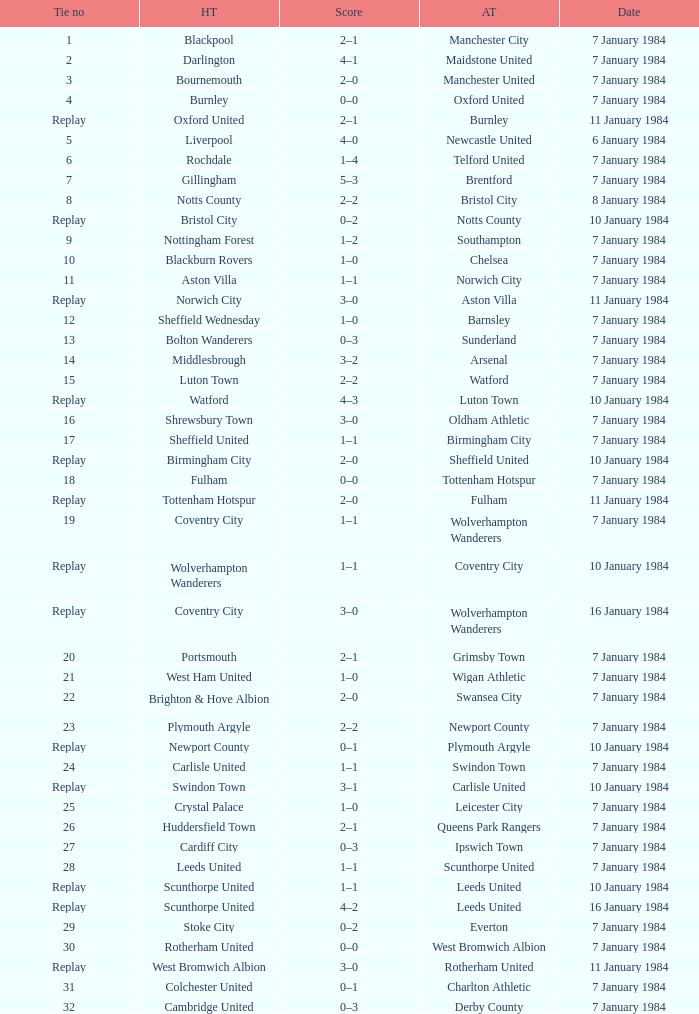Who was the away team against the home team Sheffield United? Birmingham City. Would you mind parsing the complete table? {'header': ['Tie no', 'HT', 'Score', 'AT', 'Date'], 'rows': [['1', 'Blackpool', '2–1', 'Manchester City', '7 January 1984'], ['2', 'Darlington', '4–1', 'Maidstone United', '7 January 1984'], ['3', 'Bournemouth', '2–0', 'Manchester United', '7 January 1984'], ['4', 'Burnley', '0–0', 'Oxford United', '7 January 1984'], ['Replay', 'Oxford United', '2–1', 'Burnley', '11 January 1984'], ['5', 'Liverpool', '4–0', 'Newcastle United', '6 January 1984'], ['6', 'Rochdale', '1–4', 'Telford United', '7 January 1984'], ['7', 'Gillingham', '5–3', 'Brentford', '7 January 1984'], ['8', 'Notts County', '2–2', 'Bristol City', '8 January 1984'], ['Replay', 'Bristol City', '0–2', 'Notts County', '10 January 1984'], ['9', 'Nottingham Forest', '1–2', 'Southampton', '7 January 1984'], ['10', 'Blackburn Rovers', '1–0', 'Chelsea', '7 January 1984'], ['11', 'Aston Villa', '1–1', 'Norwich City', '7 January 1984'], ['Replay', 'Norwich City', '3–0', 'Aston Villa', '11 January 1984'], ['12', 'Sheffield Wednesday', '1–0', 'Barnsley', '7 January 1984'], ['13', 'Bolton Wanderers', '0–3', 'Sunderland', '7 January 1984'], ['14', 'Middlesbrough', '3–2', 'Arsenal', '7 January 1984'], ['15', 'Luton Town', '2–2', 'Watford', '7 January 1984'], ['Replay', 'Watford', '4–3', 'Luton Town', '10 January 1984'], ['16', 'Shrewsbury Town', '3–0', 'Oldham Athletic', '7 January 1984'], ['17', 'Sheffield United', '1–1', 'Birmingham City', '7 January 1984'], ['Replay', 'Birmingham City', '2–0', 'Sheffield United', '10 January 1984'], ['18', 'Fulham', '0–0', 'Tottenham Hotspur', '7 January 1984'], ['Replay', 'Tottenham Hotspur', '2–0', 'Fulham', '11 January 1984'], ['19', 'Coventry City', '1–1', 'Wolverhampton Wanderers', '7 January 1984'], ['Replay', 'Wolverhampton Wanderers', '1–1', 'Coventry City', '10 January 1984'], ['Replay', 'Coventry City', '3–0', 'Wolverhampton Wanderers', '16 January 1984'], ['20', 'Portsmouth', '2–1', 'Grimsby Town', '7 January 1984'], ['21', 'West Ham United', '1–0', 'Wigan Athletic', '7 January 1984'], ['22', 'Brighton & Hove Albion', '2–0', 'Swansea City', '7 January 1984'], ['23', 'Plymouth Argyle', '2–2', 'Newport County', '7 January 1984'], ['Replay', 'Newport County', '0–1', 'Plymouth Argyle', '10 January 1984'], ['24', 'Carlisle United', '1–1', 'Swindon Town', '7 January 1984'], ['Replay', 'Swindon Town', '3–1', 'Carlisle United', '10 January 1984'], ['25', 'Crystal Palace', '1–0', 'Leicester City', '7 January 1984'], ['26', 'Huddersfield Town', '2–1', 'Queens Park Rangers', '7 January 1984'], ['27', 'Cardiff City', '0–3', 'Ipswich Town', '7 January 1984'], ['28', 'Leeds United', '1–1', 'Scunthorpe United', '7 January 1984'], ['Replay', 'Scunthorpe United', '1–1', 'Leeds United', '10 January 1984'], ['Replay', 'Scunthorpe United', '4–2', 'Leeds United', '16 January 1984'], ['29', 'Stoke City', '0–2', 'Everton', '7 January 1984'], ['30', 'Rotherham United', '0–0', 'West Bromwich Albion', '7 January 1984'], ['Replay', 'West Bromwich Albion', '3–0', 'Rotherham United', '11 January 1984'], ['31', 'Colchester United', '0–1', 'Charlton Athletic', '7 January 1984'], ['32', 'Cambridge United', '0–3', 'Derby County', '7 January 1984']]} 